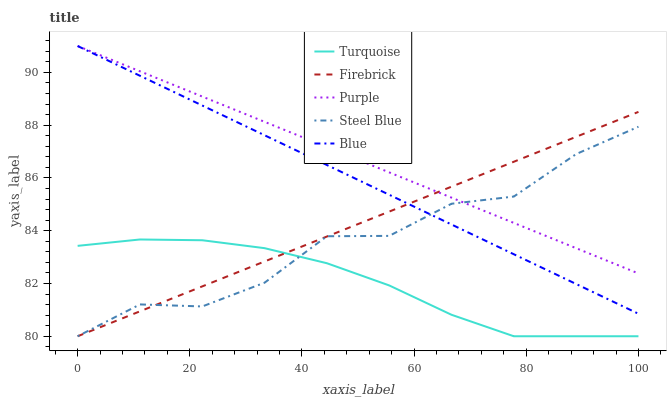Does Turquoise have the minimum area under the curve?
Answer yes or no. Yes. Does Purple have the maximum area under the curve?
Answer yes or no. Yes. Does Blue have the minimum area under the curve?
Answer yes or no. No. Does Blue have the maximum area under the curve?
Answer yes or no. No. Is Purple the smoothest?
Answer yes or no. Yes. Is Steel Blue the roughest?
Answer yes or no. Yes. Is Blue the smoothest?
Answer yes or no. No. Is Blue the roughest?
Answer yes or no. No. Does Turquoise have the lowest value?
Answer yes or no. Yes. Does Blue have the lowest value?
Answer yes or no. No. Does Blue have the highest value?
Answer yes or no. Yes. Does Turquoise have the highest value?
Answer yes or no. No. Is Turquoise less than Purple?
Answer yes or no. Yes. Is Purple greater than Turquoise?
Answer yes or no. Yes. Does Steel Blue intersect Turquoise?
Answer yes or no. Yes. Is Steel Blue less than Turquoise?
Answer yes or no. No. Is Steel Blue greater than Turquoise?
Answer yes or no. No. Does Turquoise intersect Purple?
Answer yes or no. No. 